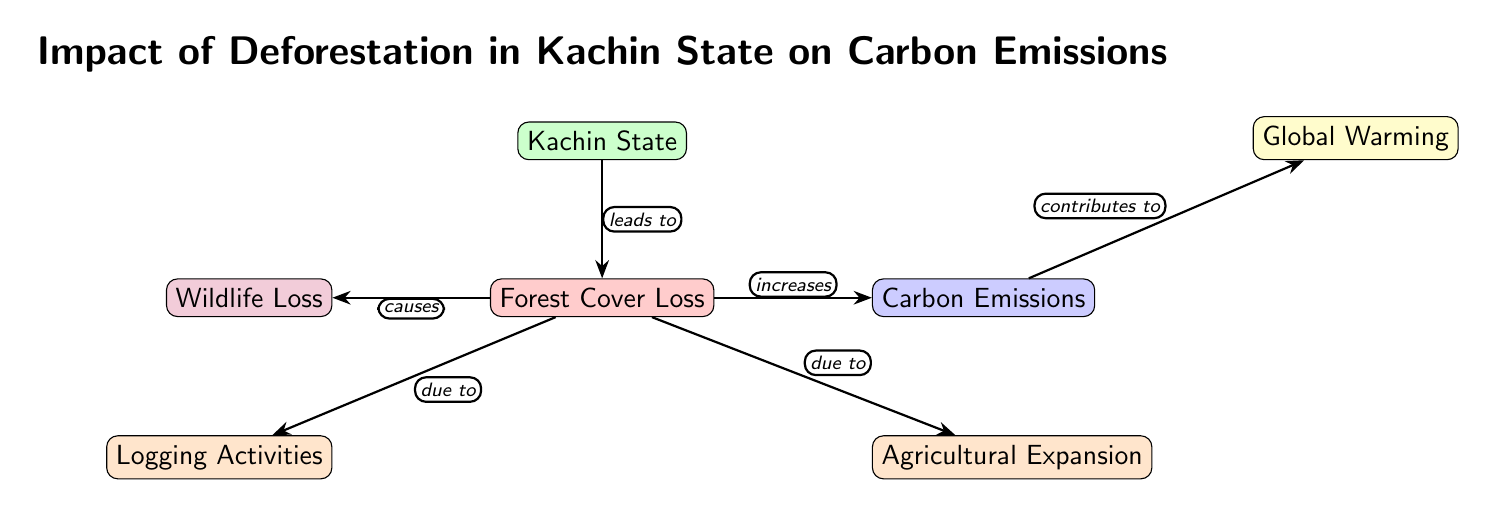What is at the top of the diagram? The topmost node in the diagram is labeled "Kachin State." This node is the starting point from which various effects and relationships are described regarding deforestation and its impacts.
Answer: Kachin State What leads to forest cover loss? The diagram indicates that both "Logging Activities" and "Agricultural Expansion" lead to "Forest Cover Loss." These are shown as nodes connected to the "Forest Cover Loss" node with the label "due to."
Answer: Logging Activities and Agricultural Expansion How many nodes are in the diagram? By counting each distinct component in the diagram, including the main node and its effects, we find there are a total of six nodes.
Answer: Six What effect does forest cover loss have on carbon emissions? The diagram demonstrates that "Forest Cover Loss" increases "Carbon Emissions." This relationship is explicitly represented by the arrow labeled "increases" going from "Forest Cover Loss" to "Carbon Emissions."
Answer: Increases What does carbon emissions contribute to? According to the diagram, "Carbon Emissions" contributes to "Global Warming." This is shown by the arrow labeled "contributes to," connecting these two concepts.
Answer: Global Warming What is caused by forest cover loss? The diagram clearly states that "Forest Cover Loss" causes "Wildlife Loss," as indicated by the connecting arrow labeled "causes."
Answer: Wildlife Loss Which node is directly related to forest cover loss? The nodes that are directly related to "Forest Cover Loss" are "Logging Activities," "Agricultural Expansion," and "Wildlife Loss." Each of these is depicted as having a relationship to "Forest Cover Loss" with directional arrows.
Answer: Logging Activities, Agricultural Expansion, and Wildlife Loss How does logging activities impact forest cover? The diagram shows that "Logging Activities" are responsible for causing "Forest Cover Loss," indicated with an arrow labeled "due to." This means that increased logging directly results in a decrease in forest area.
Answer: Causes forest cover loss What is the relationship between wildlife loss and forest cover loss? The diagram indicates that "Wildlife Loss" is caused by "Forest Cover Loss," as shown by the arrow labeled "causes," which connects the two nodes. This means that a decrease in forest area has a negative impact on wildlife.
Answer: Causes 